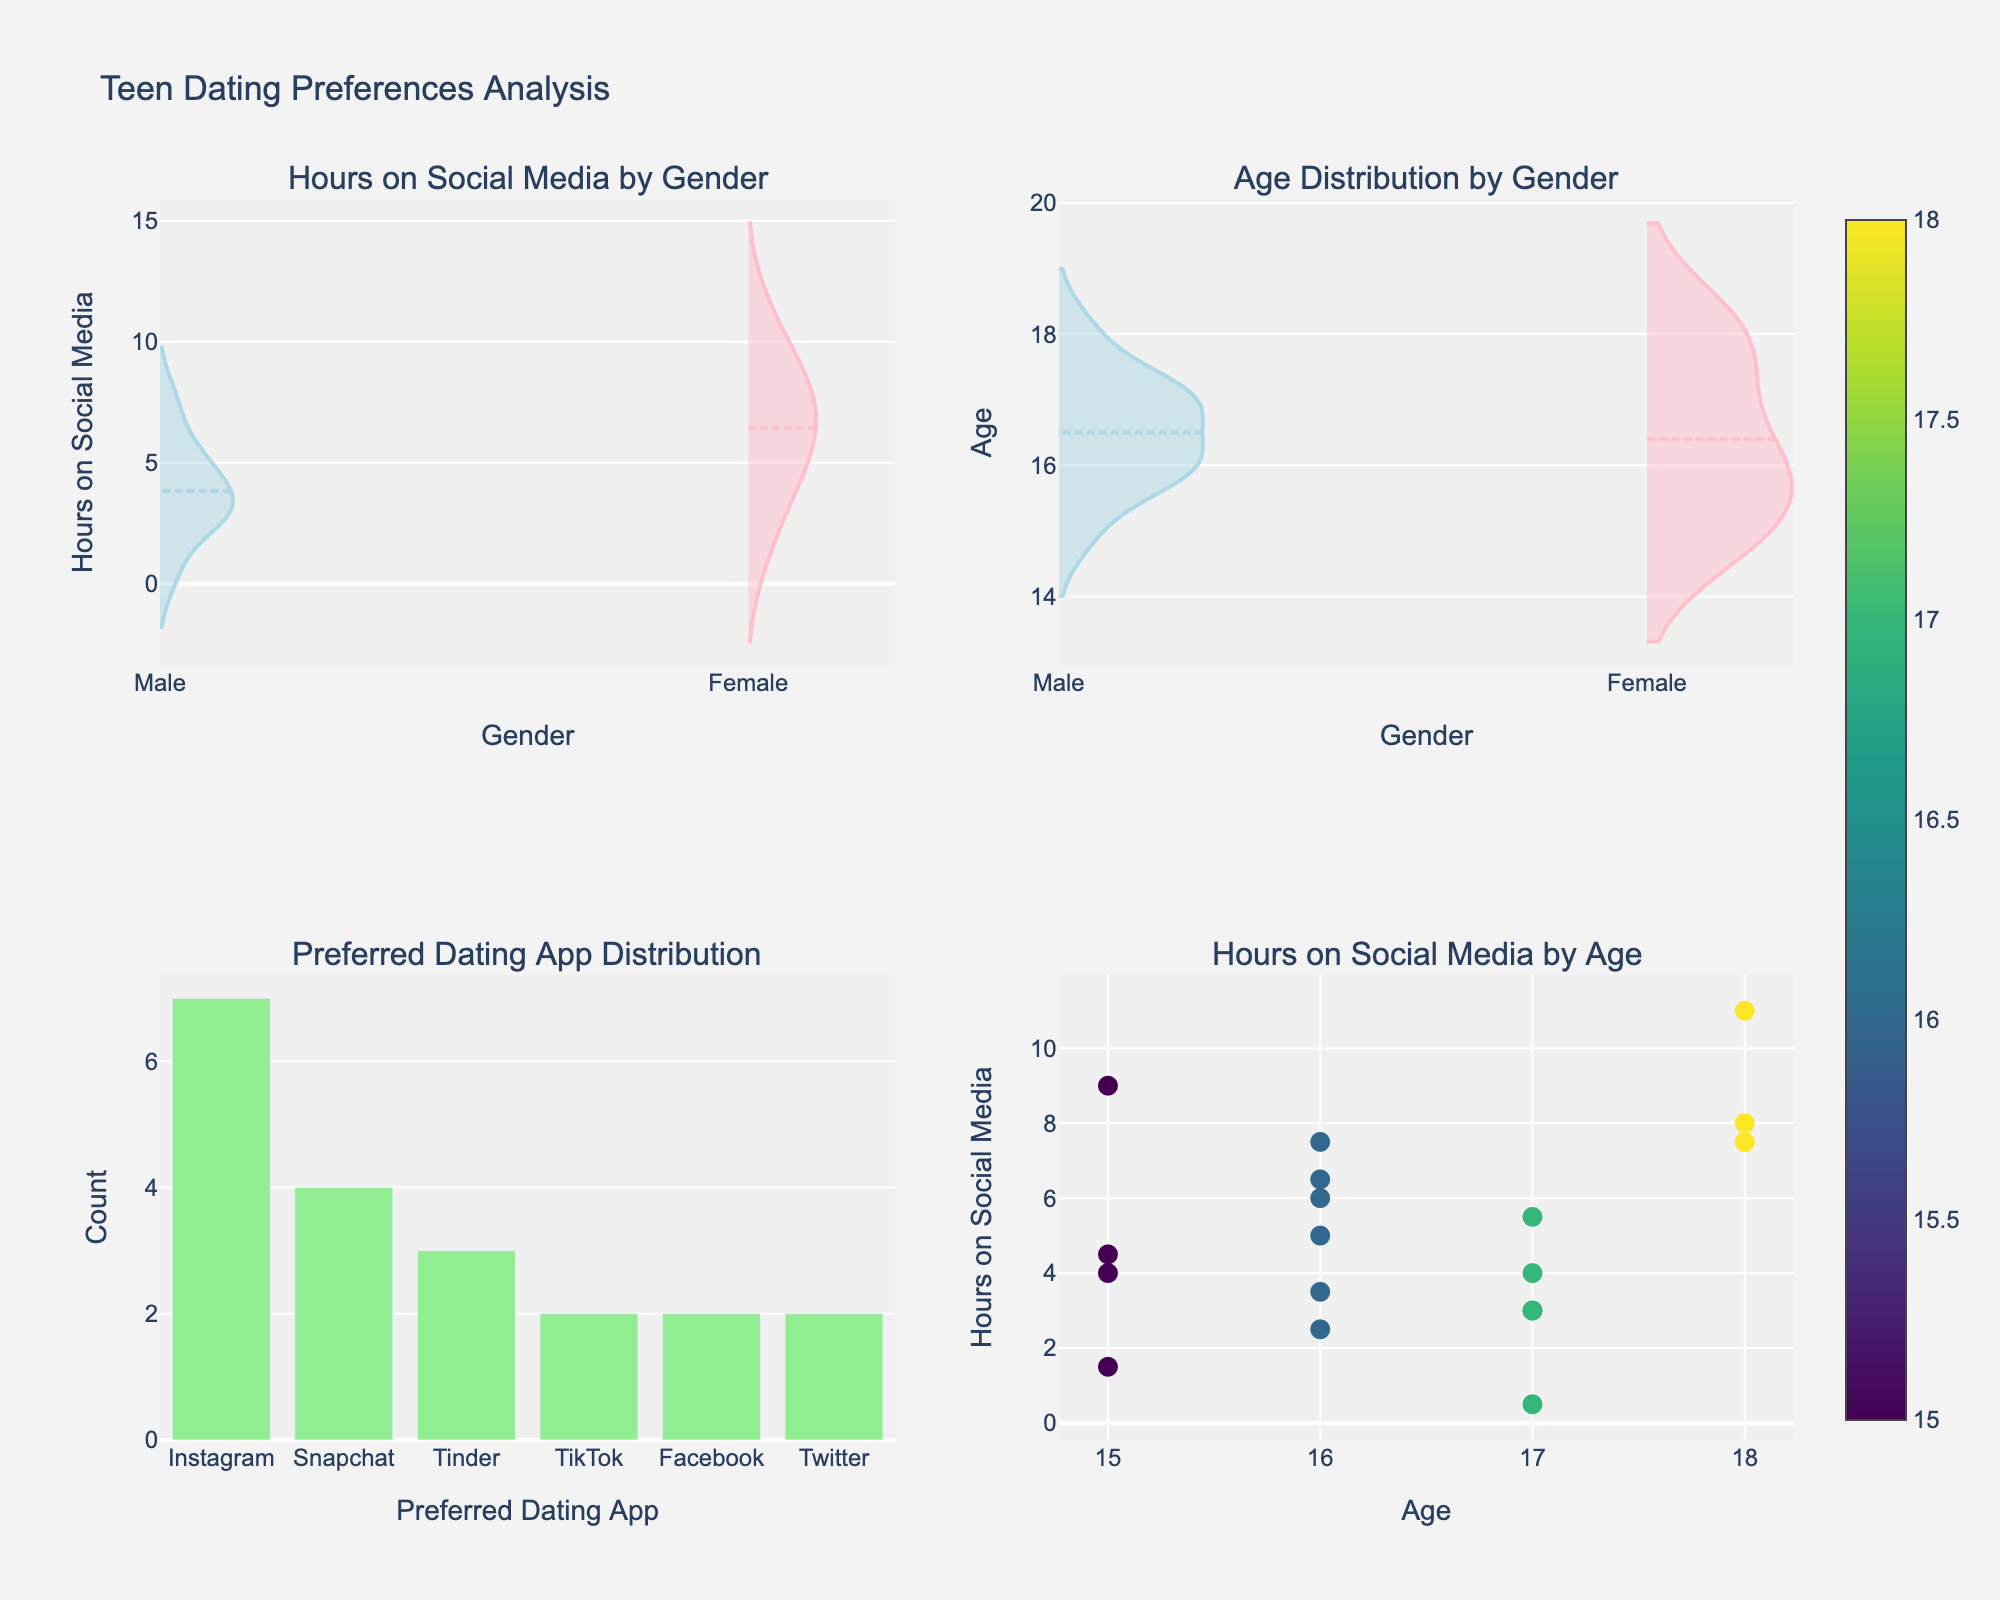What's the title of the figure? The title is usually displayed prominently at the top of the figure, indicating the main subject of the visual representation.
Answer: Teen Dating Preferences Analysis What does the subplot 'Preferred Dating App Distribution' show? This subplot shows the count of teenagers preferring different dating apps by displaying the number of counts for each app on the x-axis.
Answer: The count of teenagers preferring various dating apps Which gender has higher average hours on social media according to the subplot 'Hours on Social Media by Gender'? Observing the violin plot for 'Hours on Social Media by Gender', the mean line for each gender reveals that females have a higher average value.
Answer: Females Which dating app is most preferred among teens? In the bar chart 'Preferred Dating App Distribution', the app with the tallest bar is the most preferred one.
Answer: Instagram Are hours on social media generally trending upward or downward with age in the subplot 'Hours on Social Media by Age'? By examining the scatter plot, you can observe if the data points show an increasing or decreasing trend as age increases from left to right. Here, there seems to be a slight upward trend.
Answer: Upward What is the color used for representing females in the subplot 'Hours on Social Media by Gender'? The color used for females can be deduced from the legend or by matching the color of the visual elements corresponding to females. Based on the plot information, females are represented by pink.
Answer: Pink Between males and females, who has a wider range of 'Age Distribution by Gender'? By comparing the width of the violin plots for males and females in the 'Age Distribution by Gender', we can tell who has more variability. The range is wider for females.
Answer: Females How many different dating apps are tracked in the 'Preferred Dating App Distribution' subplot? Count the unique labels on the x-axis of the bar chart in this subplot to determine how many different apps are tracked.
Answer: Five Which gender has more teens at the age of 16 based on 'Age Distribution by Gender'? Examine the concentration and height of the violin plot at age 16 for both males and females. Females show a higher dominance around this age.
Answer: Females Which subplot uses a scatter plot? Identify the subplot showing data points in the form of individual markers, characteristic of a scatter plot. This is 'Hours on Social Media by Age'.
Answer: Hours on Social Media by Age 